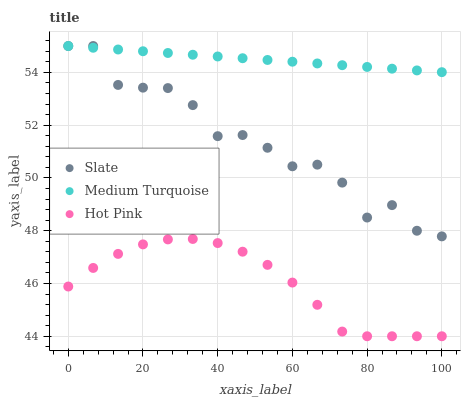Does Hot Pink have the minimum area under the curve?
Answer yes or no. Yes. Does Medium Turquoise have the maximum area under the curve?
Answer yes or no. Yes. Does Medium Turquoise have the minimum area under the curve?
Answer yes or no. No. Does Hot Pink have the maximum area under the curve?
Answer yes or no. No. Is Medium Turquoise the smoothest?
Answer yes or no. Yes. Is Slate the roughest?
Answer yes or no. Yes. Is Hot Pink the smoothest?
Answer yes or no. No. Is Hot Pink the roughest?
Answer yes or no. No. Does Hot Pink have the lowest value?
Answer yes or no. Yes. Does Medium Turquoise have the lowest value?
Answer yes or no. No. Does Medium Turquoise have the highest value?
Answer yes or no. Yes. Does Hot Pink have the highest value?
Answer yes or no. No. Is Hot Pink less than Slate?
Answer yes or no. Yes. Is Medium Turquoise greater than Hot Pink?
Answer yes or no. Yes. Does Slate intersect Medium Turquoise?
Answer yes or no. Yes. Is Slate less than Medium Turquoise?
Answer yes or no. No. Is Slate greater than Medium Turquoise?
Answer yes or no. No. Does Hot Pink intersect Slate?
Answer yes or no. No. 